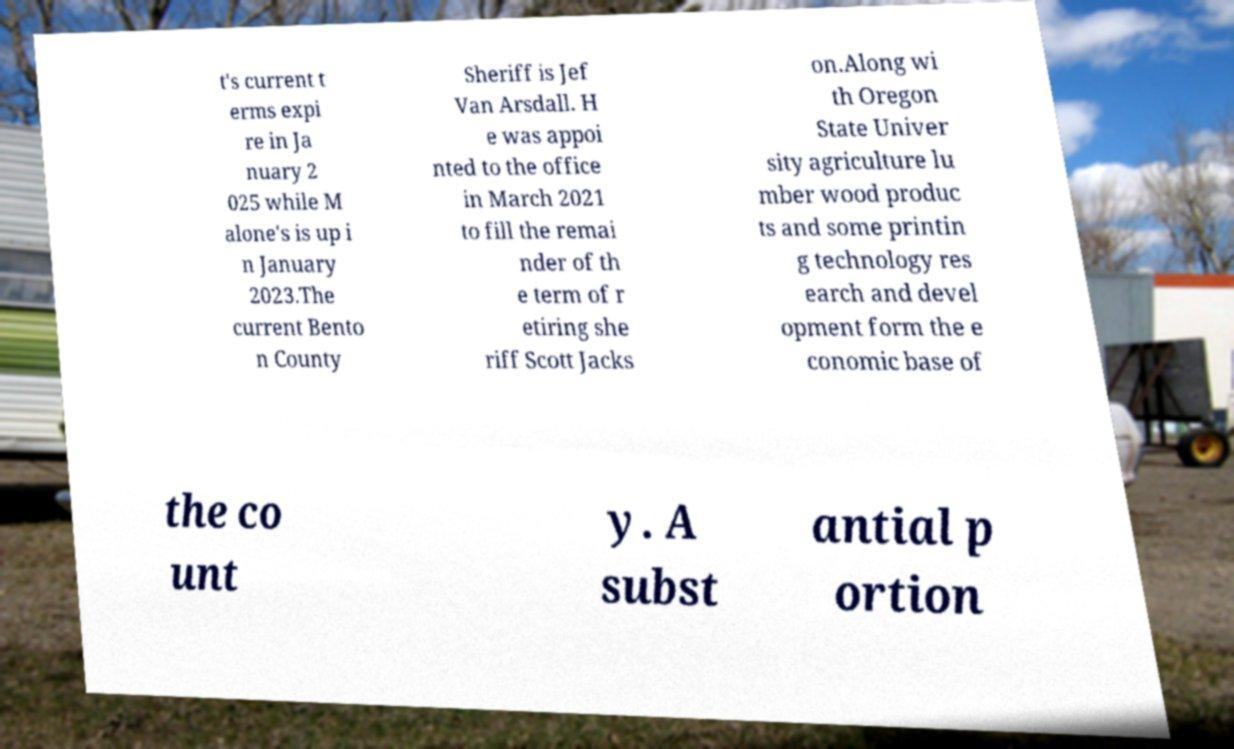Please read and relay the text visible in this image. What does it say? t's current t erms expi re in Ja nuary 2 025 while M alone's is up i n January 2023.The current Bento n County Sheriff is Jef Van Arsdall. H e was appoi nted to the office in March 2021 to fill the remai nder of th e term of r etiring she riff Scott Jacks on.Along wi th Oregon State Univer sity agriculture lu mber wood produc ts and some printin g technology res earch and devel opment form the e conomic base of the co unt y. A subst antial p ortion 